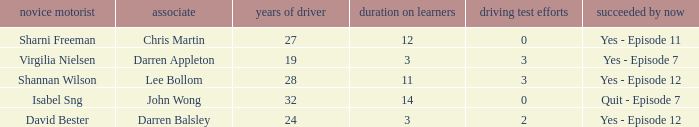Which driver is older than 24 and has more than 0 licence test attempts? Shannan Wilson. 